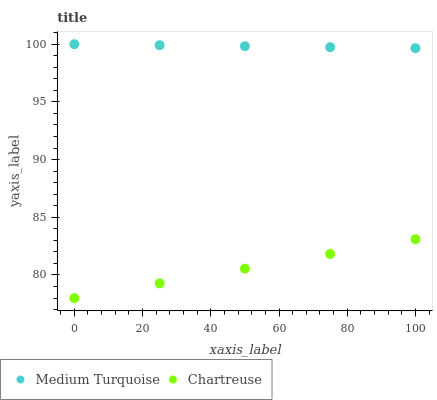Does Chartreuse have the minimum area under the curve?
Answer yes or no. Yes. Does Medium Turquoise have the maximum area under the curve?
Answer yes or no. Yes. Does Medium Turquoise have the minimum area under the curve?
Answer yes or no. No. Is Medium Turquoise the smoothest?
Answer yes or no. Yes. Is Chartreuse the roughest?
Answer yes or no. Yes. Is Medium Turquoise the roughest?
Answer yes or no. No. Does Chartreuse have the lowest value?
Answer yes or no. Yes. Does Medium Turquoise have the lowest value?
Answer yes or no. No. Does Medium Turquoise have the highest value?
Answer yes or no. Yes. Is Chartreuse less than Medium Turquoise?
Answer yes or no. Yes. Is Medium Turquoise greater than Chartreuse?
Answer yes or no. Yes. Does Chartreuse intersect Medium Turquoise?
Answer yes or no. No. 